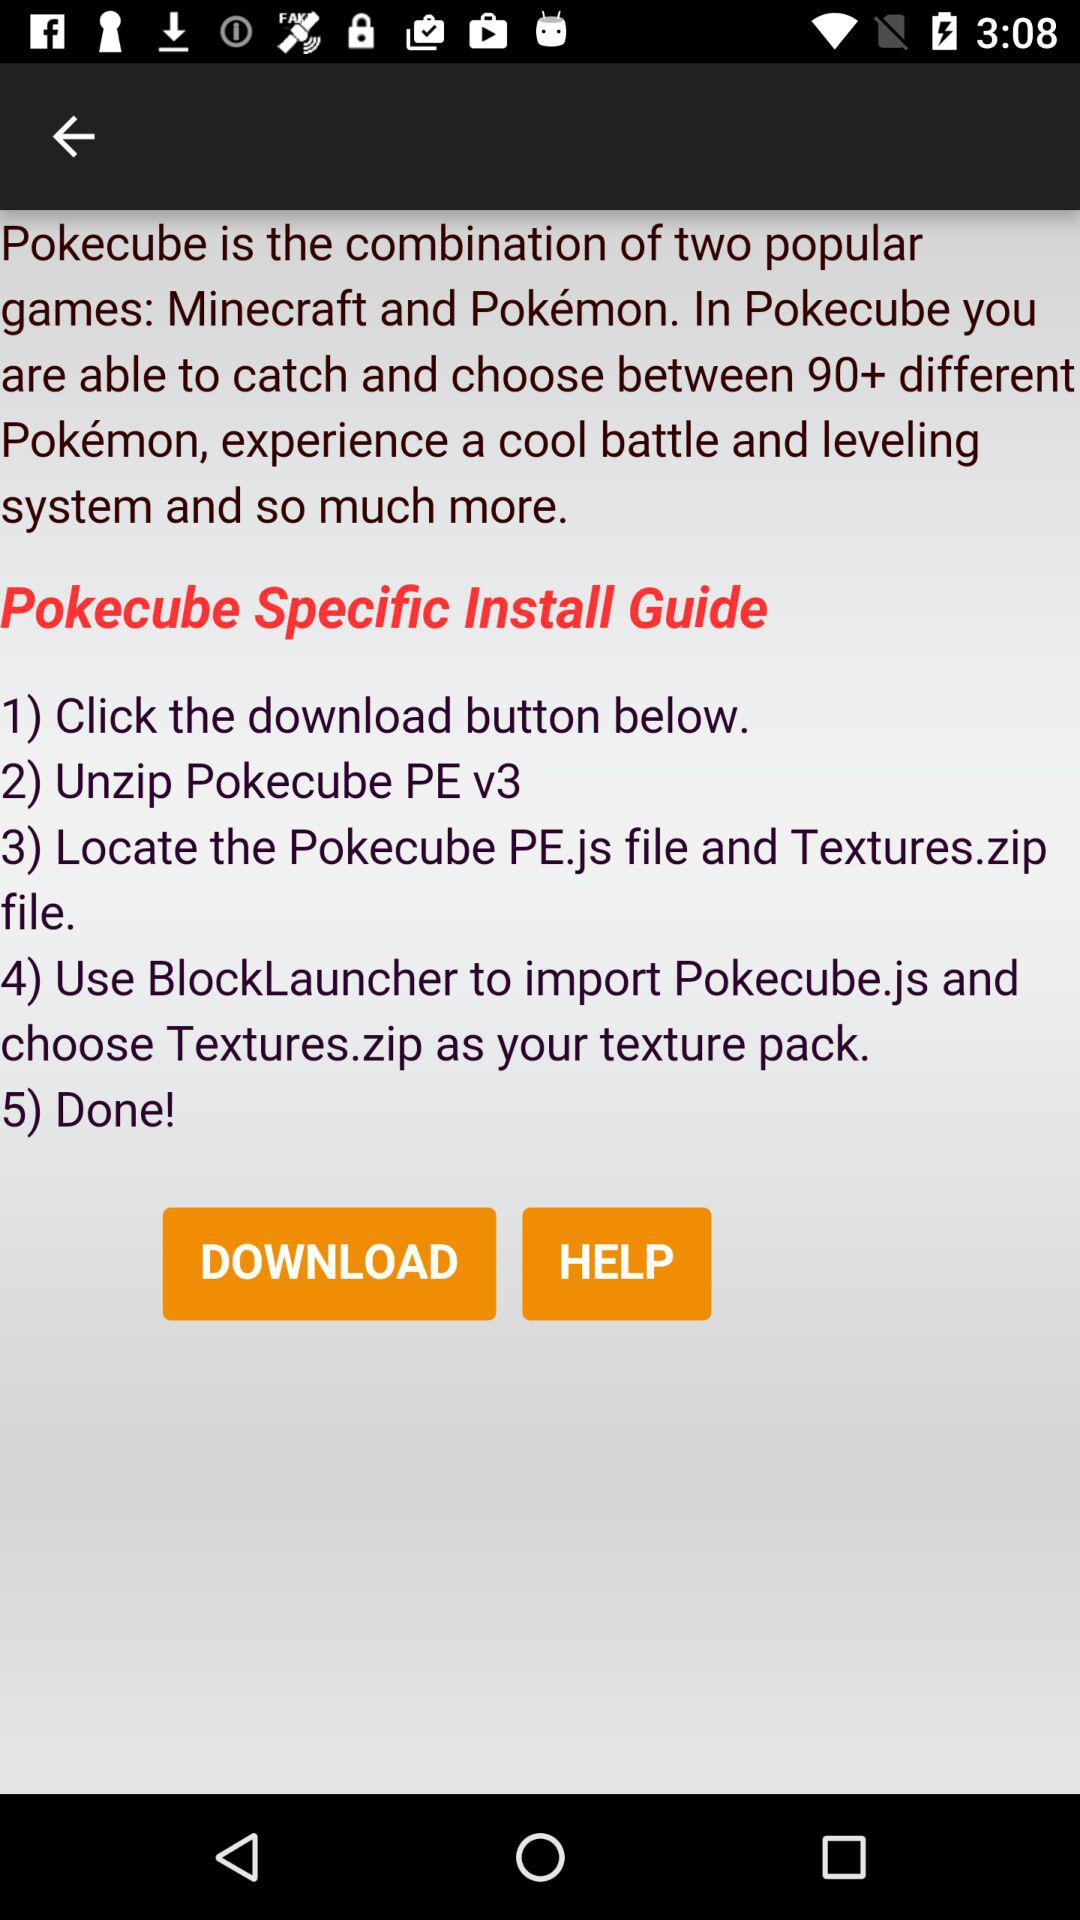How many steps are there in the Pokecube installation guide?
Answer the question using a single word or phrase. 5 